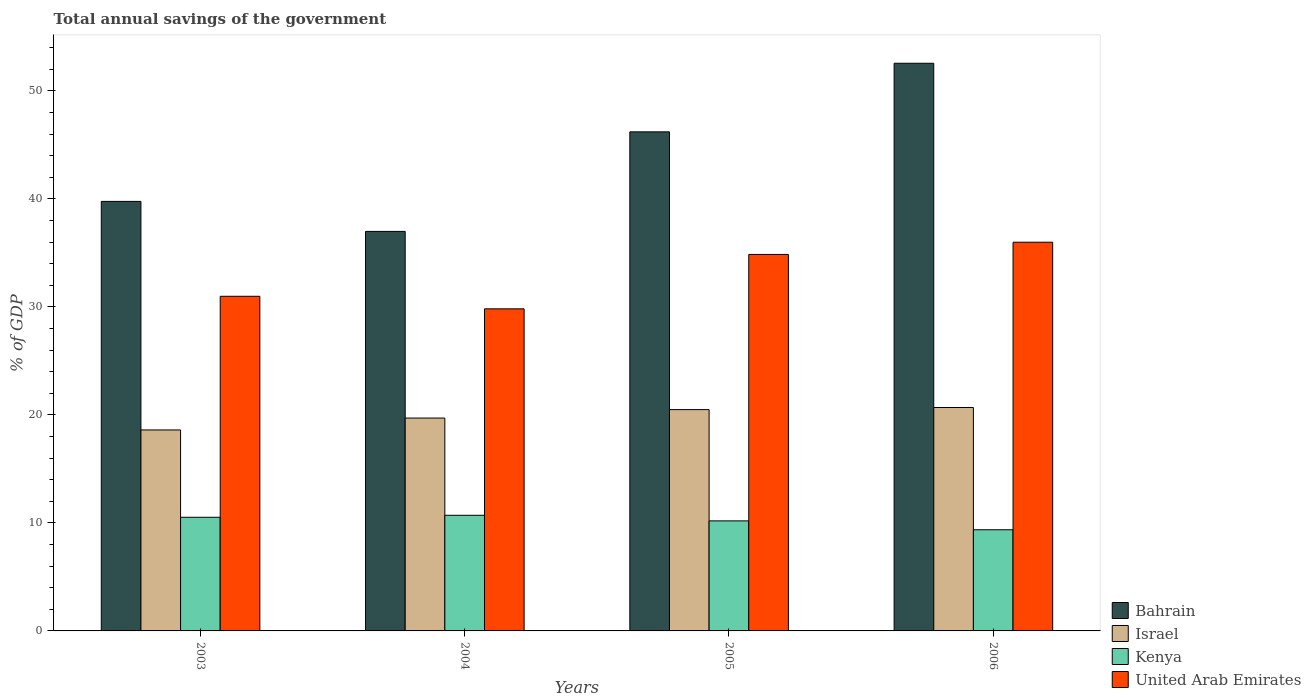Are the number of bars per tick equal to the number of legend labels?
Make the answer very short. Yes. How many bars are there on the 1st tick from the left?
Offer a terse response. 4. How many bars are there on the 1st tick from the right?
Offer a very short reply. 4. What is the label of the 4th group of bars from the left?
Offer a very short reply. 2006. What is the total annual savings of the government in Bahrain in 2004?
Provide a short and direct response. 36.99. Across all years, what is the maximum total annual savings of the government in Bahrain?
Keep it short and to the point. 52.56. Across all years, what is the minimum total annual savings of the government in Israel?
Make the answer very short. 18.61. In which year was the total annual savings of the government in Bahrain minimum?
Make the answer very short. 2004. What is the total total annual savings of the government in United Arab Emirates in the graph?
Make the answer very short. 131.65. What is the difference between the total annual savings of the government in Kenya in 2003 and that in 2004?
Keep it short and to the point. -0.18. What is the difference between the total annual savings of the government in Bahrain in 2005 and the total annual savings of the government in Israel in 2003?
Make the answer very short. 27.6. What is the average total annual savings of the government in United Arab Emirates per year?
Provide a succinct answer. 32.91. In the year 2005, what is the difference between the total annual savings of the government in United Arab Emirates and total annual savings of the government in Bahrain?
Provide a succinct answer. -11.35. In how many years, is the total annual savings of the government in United Arab Emirates greater than 6 %?
Your answer should be very brief. 4. What is the ratio of the total annual savings of the government in United Arab Emirates in 2003 to that in 2005?
Make the answer very short. 0.89. Is the total annual savings of the government in Bahrain in 2004 less than that in 2006?
Your answer should be compact. Yes. Is the difference between the total annual savings of the government in United Arab Emirates in 2005 and 2006 greater than the difference between the total annual savings of the government in Bahrain in 2005 and 2006?
Offer a very short reply. Yes. What is the difference between the highest and the second highest total annual savings of the government in Kenya?
Offer a very short reply. 0.18. What is the difference between the highest and the lowest total annual savings of the government in Kenya?
Your answer should be very brief. 1.34. In how many years, is the total annual savings of the government in United Arab Emirates greater than the average total annual savings of the government in United Arab Emirates taken over all years?
Ensure brevity in your answer.  2. Is the sum of the total annual savings of the government in Israel in 2003 and 2005 greater than the maximum total annual savings of the government in United Arab Emirates across all years?
Your answer should be compact. Yes. What does the 2nd bar from the left in 2003 represents?
Provide a succinct answer. Israel. Is it the case that in every year, the sum of the total annual savings of the government in United Arab Emirates and total annual savings of the government in Bahrain is greater than the total annual savings of the government in Israel?
Give a very brief answer. Yes. How many bars are there?
Provide a short and direct response. 16. Are all the bars in the graph horizontal?
Keep it short and to the point. No. Are the values on the major ticks of Y-axis written in scientific E-notation?
Your response must be concise. No. Does the graph contain any zero values?
Your answer should be compact. No. Does the graph contain grids?
Provide a succinct answer. No. How are the legend labels stacked?
Make the answer very short. Vertical. What is the title of the graph?
Offer a terse response. Total annual savings of the government. Does "Myanmar" appear as one of the legend labels in the graph?
Provide a short and direct response. No. What is the label or title of the X-axis?
Ensure brevity in your answer.  Years. What is the label or title of the Y-axis?
Give a very brief answer. % of GDP. What is the % of GDP in Bahrain in 2003?
Keep it short and to the point. 39.77. What is the % of GDP in Israel in 2003?
Provide a succinct answer. 18.61. What is the % of GDP in Kenya in 2003?
Your answer should be very brief. 10.52. What is the % of GDP of United Arab Emirates in 2003?
Keep it short and to the point. 30.98. What is the % of GDP in Bahrain in 2004?
Your answer should be very brief. 36.99. What is the % of GDP in Israel in 2004?
Provide a succinct answer. 19.71. What is the % of GDP in Kenya in 2004?
Provide a short and direct response. 10.71. What is the % of GDP of United Arab Emirates in 2004?
Provide a short and direct response. 29.82. What is the % of GDP of Bahrain in 2005?
Provide a short and direct response. 46.21. What is the % of GDP in Israel in 2005?
Keep it short and to the point. 20.49. What is the % of GDP in Kenya in 2005?
Keep it short and to the point. 10.19. What is the % of GDP of United Arab Emirates in 2005?
Offer a terse response. 34.86. What is the % of GDP in Bahrain in 2006?
Keep it short and to the point. 52.56. What is the % of GDP of Israel in 2006?
Provide a succinct answer. 20.69. What is the % of GDP in Kenya in 2006?
Ensure brevity in your answer.  9.37. What is the % of GDP of United Arab Emirates in 2006?
Offer a terse response. 35.99. Across all years, what is the maximum % of GDP of Bahrain?
Your response must be concise. 52.56. Across all years, what is the maximum % of GDP of Israel?
Your answer should be very brief. 20.69. Across all years, what is the maximum % of GDP of Kenya?
Offer a terse response. 10.71. Across all years, what is the maximum % of GDP of United Arab Emirates?
Provide a short and direct response. 35.99. Across all years, what is the minimum % of GDP in Bahrain?
Offer a terse response. 36.99. Across all years, what is the minimum % of GDP of Israel?
Provide a short and direct response. 18.61. Across all years, what is the minimum % of GDP in Kenya?
Provide a succinct answer. 9.37. Across all years, what is the minimum % of GDP in United Arab Emirates?
Your answer should be very brief. 29.82. What is the total % of GDP of Bahrain in the graph?
Ensure brevity in your answer.  175.53. What is the total % of GDP in Israel in the graph?
Offer a very short reply. 79.5. What is the total % of GDP in Kenya in the graph?
Offer a very short reply. 40.79. What is the total % of GDP of United Arab Emirates in the graph?
Provide a short and direct response. 131.65. What is the difference between the % of GDP of Bahrain in 2003 and that in 2004?
Your response must be concise. 2.78. What is the difference between the % of GDP of Israel in 2003 and that in 2004?
Make the answer very short. -1.1. What is the difference between the % of GDP in Kenya in 2003 and that in 2004?
Offer a terse response. -0.18. What is the difference between the % of GDP of United Arab Emirates in 2003 and that in 2004?
Ensure brevity in your answer.  1.16. What is the difference between the % of GDP in Bahrain in 2003 and that in 2005?
Provide a succinct answer. -6.44. What is the difference between the % of GDP of Israel in 2003 and that in 2005?
Provide a succinct answer. -1.88. What is the difference between the % of GDP of Kenya in 2003 and that in 2005?
Your answer should be very brief. 0.33. What is the difference between the % of GDP of United Arab Emirates in 2003 and that in 2005?
Provide a succinct answer. -3.88. What is the difference between the % of GDP in Bahrain in 2003 and that in 2006?
Your answer should be compact. -12.79. What is the difference between the % of GDP in Israel in 2003 and that in 2006?
Provide a succinct answer. -2.08. What is the difference between the % of GDP of Kenya in 2003 and that in 2006?
Provide a succinct answer. 1.16. What is the difference between the % of GDP of United Arab Emirates in 2003 and that in 2006?
Give a very brief answer. -5.01. What is the difference between the % of GDP in Bahrain in 2004 and that in 2005?
Make the answer very short. -9.22. What is the difference between the % of GDP of Israel in 2004 and that in 2005?
Give a very brief answer. -0.78. What is the difference between the % of GDP of Kenya in 2004 and that in 2005?
Your answer should be compact. 0.52. What is the difference between the % of GDP in United Arab Emirates in 2004 and that in 2005?
Keep it short and to the point. -5.04. What is the difference between the % of GDP in Bahrain in 2004 and that in 2006?
Offer a terse response. -15.57. What is the difference between the % of GDP in Israel in 2004 and that in 2006?
Provide a succinct answer. -0.98. What is the difference between the % of GDP in Kenya in 2004 and that in 2006?
Offer a terse response. 1.34. What is the difference between the % of GDP in United Arab Emirates in 2004 and that in 2006?
Make the answer very short. -6.17. What is the difference between the % of GDP in Bahrain in 2005 and that in 2006?
Your answer should be compact. -6.35. What is the difference between the % of GDP of Israel in 2005 and that in 2006?
Your answer should be compact. -0.19. What is the difference between the % of GDP of Kenya in 2005 and that in 2006?
Keep it short and to the point. 0.82. What is the difference between the % of GDP of United Arab Emirates in 2005 and that in 2006?
Keep it short and to the point. -1.13. What is the difference between the % of GDP of Bahrain in 2003 and the % of GDP of Israel in 2004?
Provide a succinct answer. 20.06. What is the difference between the % of GDP of Bahrain in 2003 and the % of GDP of Kenya in 2004?
Make the answer very short. 29.06. What is the difference between the % of GDP of Bahrain in 2003 and the % of GDP of United Arab Emirates in 2004?
Give a very brief answer. 9.95. What is the difference between the % of GDP of Israel in 2003 and the % of GDP of Kenya in 2004?
Give a very brief answer. 7.9. What is the difference between the % of GDP in Israel in 2003 and the % of GDP in United Arab Emirates in 2004?
Your response must be concise. -11.21. What is the difference between the % of GDP of Kenya in 2003 and the % of GDP of United Arab Emirates in 2004?
Keep it short and to the point. -19.3. What is the difference between the % of GDP of Bahrain in 2003 and the % of GDP of Israel in 2005?
Provide a succinct answer. 19.28. What is the difference between the % of GDP in Bahrain in 2003 and the % of GDP in Kenya in 2005?
Your answer should be compact. 29.58. What is the difference between the % of GDP in Bahrain in 2003 and the % of GDP in United Arab Emirates in 2005?
Ensure brevity in your answer.  4.91. What is the difference between the % of GDP of Israel in 2003 and the % of GDP of Kenya in 2005?
Provide a short and direct response. 8.42. What is the difference between the % of GDP in Israel in 2003 and the % of GDP in United Arab Emirates in 2005?
Ensure brevity in your answer.  -16.25. What is the difference between the % of GDP in Kenya in 2003 and the % of GDP in United Arab Emirates in 2005?
Offer a terse response. -24.34. What is the difference between the % of GDP of Bahrain in 2003 and the % of GDP of Israel in 2006?
Your answer should be very brief. 19.08. What is the difference between the % of GDP of Bahrain in 2003 and the % of GDP of Kenya in 2006?
Make the answer very short. 30.4. What is the difference between the % of GDP of Bahrain in 2003 and the % of GDP of United Arab Emirates in 2006?
Your answer should be compact. 3.78. What is the difference between the % of GDP in Israel in 2003 and the % of GDP in Kenya in 2006?
Keep it short and to the point. 9.24. What is the difference between the % of GDP of Israel in 2003 and the % of GDP of United Arab Emirates in 2006?
Your response must be concise. -17.38. What is the difference between the % of GDP in Kenya in 2003 and the % of GDP in United Arab Emirates in 2006?
Your answer should be compact. -25.47. What is the difference between the % of GDP of Bahrain in 2004 and the % of GDP of Israel in 2005?
Your answer should be very brief. 16.5. What is the difference between the % of GDP of Bahrain in 2004 and the % of GDP of Kenya in 2005?
Provide a succinct answer. 26.8. What is the difference between the % of GDP of Bahrain in 2004 and the % of GDP of United Arab Emirates in 2005?
Make the answer very short. 2.13. What is the difference between the % of GDP in Israel in 2004 and the % of GDP in Kenya in 2005?
Give a very brief answer. 9.52. What is the difference between the % of GDP in Israel in 2004 and the % of GDP in United Arab Emirates in 2005?
Your answer should be very brief. -15.15. What is the difference between the % of GDP in Kenya in 2004 and the % of GDP in United Arab Emirates in 2005?
Make the answer very short. -24.15. What is the difference between the % of GDP in Bahrain in 2004 and the % of GDP in Israel in 2006?
Offer a very short reply. 16.31. What is the difference between the % of GDP in Bahrain in 2004 and the % of GDP in Kenya in 2006?
Your answer should be very brief. 27.63. What is the difference between the % of GDP of Bahrain in 2004 and the % of GDP of United Arab Emirates in 2006?
Offer a terse response. 1. What is the difference between the % of GDP of Israel in 2004 and the % of GDP of Kenya in 2006?
Offer a very short reply. 10.34. What is the difference between the % of GDP of Israel in 2004 and the % of GDP of United Arab Emirates in 2006?
Provide a succinct answer. -16.28. What is the difference between the % of GDP of Kenya in 2004 and the % of GDP of United Arab Emirates in 2006?
Give a very brief answer. -25.28. What is the difference between the % of GDP of Bahrain in 2005 and the % of GDP of Israel in 2006?
Provide a short and direct response. 25.52. What is the difference between the % of GDP of Bahrain in 2005 and the % of GDP of Kenya in 2006?
Offer a very short reply. 36.84. What is the difference between the % of GDP in Bahrain in 2005 and the % of GDP in United Arab Emirates in 2006?
Offer a terse response. 10.22. What is the difference between the % of GDP in Israel in 2005 and the % of GDP in Kenya in 2006?
Your answer should be compact. 11.13. What is the difference between the % of GDP in Israel in 2005 and the % of GDP in United Arab Emirates in 2006?
Your response must be concise. -15.5. What is the difference between the % of GDP in Kenya in 2005 and the % of GDP in United Arab Emirates in 2006?
Your answer should be very brief. -25.8. What is the average % of GDP of Bahrain per year?
Your response must be concise. 43.88. What is the average % of GDP of Israel per year?
Ensure brevity in your answer.  19.87. What is the average % of GDP of Kenya per year?
Provide a succinct answer. 10.2. What is the average % of GDP of United Arab Emirates per year?
Make the answer very short. 32.91. In the year 2003, what is the difference between the % of GDP of Bahrain and % of GDP of Israel?
Your response must be concise. 21.16. In the year 2003, what is the difference between the % of GDP in Bahrain and % of GDP in Kenya?
Keep it short and to the point. 29.25. In the year 2003, what is the difference between the % of GDP of Bahrain and % of GDP of United Arab Emirates?
Provide a short and direct response. 8.79. In the year 2003, what is the difference between the % of GDP of Israel and % of GDP of Kenya?
Ensure brevity in your answer.  8.09. In the year 2003, what is the difference between the % of GDP in Israel and % of GDP in United Arab Emirates?
Keep it short and to the point. -12.37. In the year 2003, what is the difference between the % of GDP in Kenya and % of GDP in United Arab Emirates?
Your answer should be compact. -20.46. In the year 2004, what is the difference between the % of GDP of Bahrain and % of GDP of Israel?
Your answer should be compact. 17.28. In the year 2004, what is the difference between the % of GDP in Bahrain and % of GDP in Kenya?
Your response must be concise. 26.29. In the year 2004, what is the difference between the % of GDP in Bahrain and % of GDP in United Arab Emirates?
Your response must be concise. 7.17. In the year 2004, what is the difference between the % of GDP of Israel and % of GDP of Kenya?
Keep it short and to the point. 9. In the year 2004, what is the difference between the % of GDP of Israel and % of GDP of United Arab Emirates?
Ensure brevity in your answer.  -10.11. In the year 2004, what is the difference between the % of GDP of Kenya and % of GDP of United Arab Emirates?
Your answer should be compact. -19.12. In the year 2005, what is the difference between the % of GDP in Bahrain and % of GDP in Israel?
Your response must be concise. 25.72. In the year 2005, what is the difference between the % of GDP of Bahrain and % of GDP of Kenya?
Provide a short and direct response. 36.02. In the year 2005, what is the difference between the % of GDP of Bahrain and % of GDP of United Arab Emirates?
Offer a very short reply. 11.35. In the year 2005, what is the difference between the % of GDP of Israel and % of GDP of Kenya?
Make the answer very short. 10.3. In the year 2005, what is the difference between the % of GDP of Israel and % of GDP of United Arab Emirates?
Ensure brevity in your answer.  -14.37. In the year 2005, what is the difference between the % of GDP of Kenya and % of GDP of United Arab Emirates?
Make the answer very short. -24.67. In the year 2006, what is the difference between the % of GDP of Bahrain and % of GDP of Israel?
Make the answer very short. 31.88. In the year 2006, what is the difference between the % of GDP of Bahrain and % of GDP of Kenya?
Offer a terse response. 43.19. In the year 2006, what is the difference between the % of GDP in Bahrain and % of GDP in United Arab Emirates?
Your answer should be compact. 16.57. In the year 2006, what is the difference between the % of GDP in Israel and % of GDP in Kenya?
Your response must be concise. 11.32. In the year 2006, what is the difference between the % of GDP of Israel and % of GDP of United Arab Emirates?
Your response must be concise. -15.3. In the year 2006, what is the difference between the % of GDP of Kenya and % of GDP of United Arab Emirates?
Keep it short and to the point. -26.62. What is the ratio of the % of GDP in Bahrain in 2003 to that in 2004?
Give a very brief answer. 1.08. What is the ratio of the % of GDP in Israel in 2003 to that in 2004?
Your answer should be very brief. 0.94. What is the ratio of the % of GDP of United Arab Emirates in 2003 to that in 2004?
Provide a succinct answer. 1.04. What is the ratio of the % of GDP in Bahrain in 2003 to that in 2005?
Your answer should be compact. 0.86. What is the ratio of the % of GDP in Israel in 2003 to that in 2005?
Give a very brief answer. 0.91. What is the ratio of the % of GDP in Kenya in 2003 to that in 2005?
Provide a succinct answer. 1.03. What is the ratio of the % of GDP of United Arab Emirates in 2003 to that in 2005?
Your answer should be very brief. 0.89. What is the ratio of the % of GDP in Bahrain in 2003 to that in 2006?
Offer a terse response. 0.76. What is the ratio of the % of GDP in Israel in 2003 to that in 2006?
Your answer should be very brief. 0.9. What is the ratio of the % of GDP in Kenya in 2003 to that in 2006?
Provide a short and direct response. 1.12. What is the ratio of the % of GDP in United Arab Emirates in 2003 to that in 2006?
Provide a succinct answer. 0.86. What is the ratio of the % of GDP in Bahrain in 2004 to that in 2005?
Make the answer very short. 0.8. What is the ratio of the % of GDP in Israel in 2004 to that in 2005?
Ensure brevity in your answer.  0.96. What is the ratio of the % of GDP of Kenya in 2004 to that in 2005?
Your answer should be compact. 1.05. What is the ratio of the % of GDP in United Arab Emirates in 2004 to that in 2005?
Ensure brevity in your answer.  0.86. What is the ratio of the % of GDP in Bahrain in 2004 to that in 2006?
Offer a terse response. 0.7. What is the ratio of the % of GDP of Israel in 2004 to that in 2006?
Provide a short and direct response. 0.95. What is the ratio of the % of GDP in Kenya in 2004 to that in 2006?
Provide a succinct answer. 1.14. What is the ratio of the % of GDP in United Arab Emirates in 2004 to that in 2006?
Provide a succinct answer. 0.83. What is the ratio of the % of GDP in Bahrain in 2005 to that in 2006?
Offer a very short reply. 0.88. What is the ratio of the % of GDP of Israel in 2005 to that in 2006?
Offer a very short reply. 0.99. What is the ratio of the % of GDP in Kenya in 2005 to that in 2006?
Your answer should be very brief. 1.09. What is the ratio of the % of GDP of United Arab Emirates in 2005 to that in 2006?
Offer a very short reply. 0.97. What is the difference between the highest and the second highest % of GDP of Bahrain?
Provide a short and direct response. 6.35. What is the difference between the highest and the second highest % of GDP of Israel?
Your answer should be compact. 0.19. What is the difference between the highest and the second highest % of GDP in Kenya?
Provide a succinct answer. 0.18. What is the difference between the highest and the second highest % of GDP of United Arab Emirates?
Your answer should be compact. 1.13. What is the difference between the highest and the lowest % of GDP in Bahrain?
Offer a terse response. 15.57. What is the difference between the highest and the lowest % of GDP in Israel?
Offer a terse response. 2.08. What is the difference between the highest and the lowest % of GDP of Kenya?
Ensure brevity in your answer.  1.34. What is the difference between the highest and the lowest % of GDP in United Arab Emirates?
Provide a short and direct response. 6.17. 